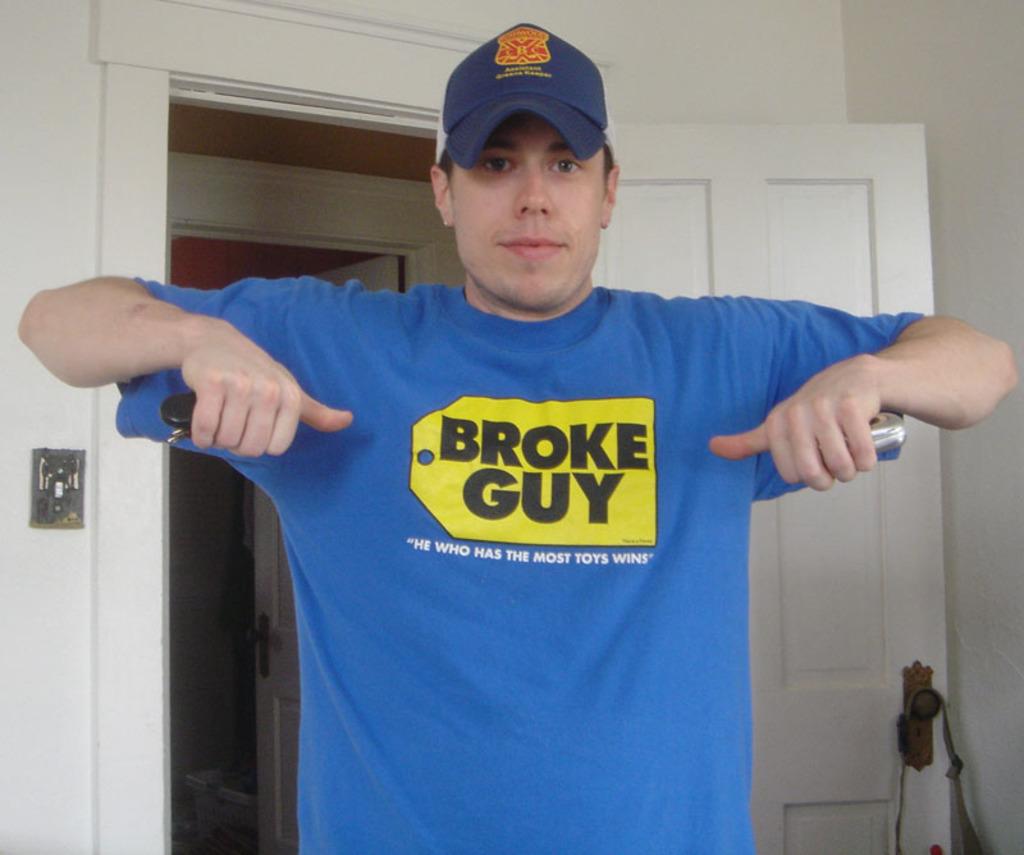What kind of guy?
Make the answer very short. Broke. 